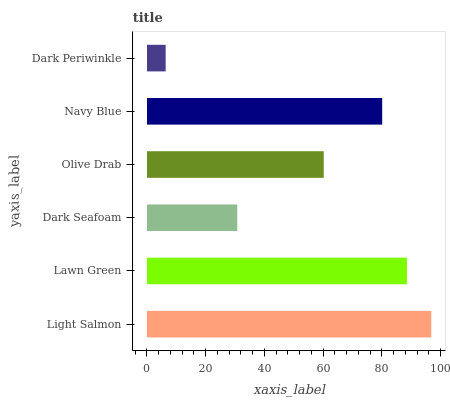Is Dark Periwinkle the minimum?
Answer yes or no. Yes. Is Light Salmon the maximum?
Answer yes or no. Yes. Is Lawn Green the minimum?
Answer yes or no. No. Is Lawn Green the maximum?
Answer yes or no. No. Is Light Salmon greater than Lawn Green?
Answer yes or no. Yes. Is Lawn Green less than Light Salmon?
Answer yes or no. Yes. Is Lawn Green greater than Light Salmon?
Answer yes or no. No. Is Light Salmon less than Lawn Green?
Answer yes or no. No. Is Navy Blue the high median?
Answer yes or no. Yes. Is Olive Drab the low median?
Answer yes or no. Yes. Is Dark Seafoam the high median?
Answer yes or no. No. Is Navy Blue the low median?
Answer yes or no. No. 